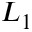<formula> <loc_0><loc_0><loc_500><loc_500>L _ { 1 }</formula> 